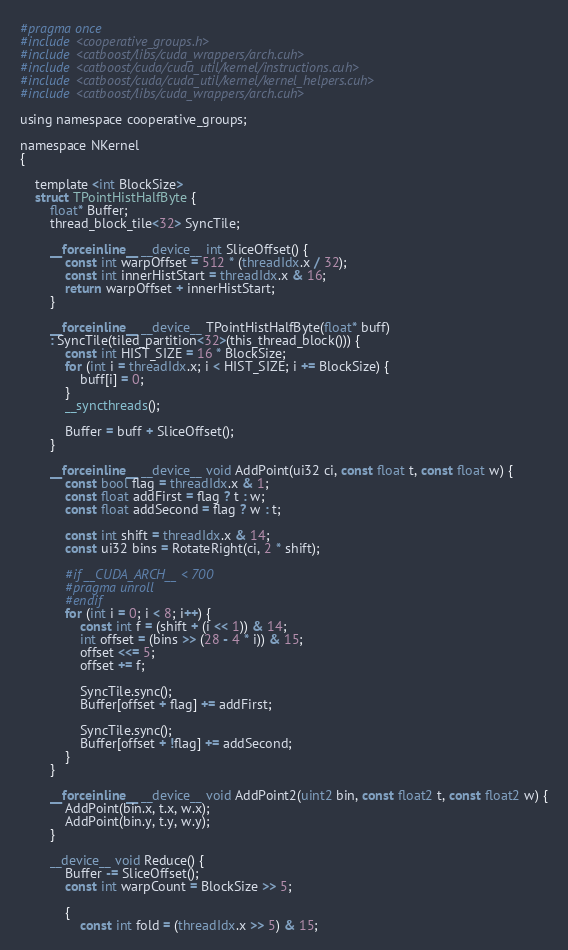<code> <loc_0><loc_0><loc_500><loc_500><_Cuda_>#pragma once
#include <cooperative_groups.h>
#include <catboost/libs/cuda_wrappers/arch.cuh>
#include <catboost/cuda/cuda_util/kernel/instructions.cuh>
#include <catboost/cuda/cuda_util/kernel/kernel_helpers.cuh>
#include <catboost/libs/cuda_wrappers/arch.cuh>

using namespace cooperative_groups;

namespace NKernel
{

    template <int BlockSize>
    struct TPointHistHalfByte {
        float* Buffer;
        thread_block_tile<32> SyncTile;

        __forceinline__ __device__ int SliceOffset() {
            const int warpOffset = 512 * (threadIdx.x / 32);
            const int innerHistStart = threadIdx.x & 16;
            return warpOffset + innerHistStart;
        }

        __forceinline__ __device__ TPointHistHalfByte(float* buff)
        : SyncTile(tiled_partition<32>(this_thread_block())) {
            const int HIST_SIZE = 16 * BlockSize;
            for (int i = threadIdx.x; i < HIST_SIZE; i += BlockSize) {
                buff[i] = 0;
            }
            __syncthreads();

            Buffer = buff + SliceOffset();
        }

        __forceinline__ __device__ void AddPoint(ui32 ci, const float t, const float w) {
            const bool flag = threadIdx.x & 1;
            const float addFirst = flag ? t : w;
            const float addSecond = flag ? w : t;

            const int shift = threadIdx.x & 14;
            const ui32 bins = RotateRight(ci, 2 * shift);

            #if __CUDA_ARCH__ < 700
            #pragma unroll
            #endif
            for (int i = 0; i < 8; i++) {
                const int f = (shift + (i << 1)) & 14;
                int offset = (bins >> (28 - 4 * i)) & 15;
                offset <<= 5;
                offset += f;

                SyncTile.sync();
                Buffer[offset + flag] += addFirst;

                SyncTile.sync();
                Buffer[offset + !flag] += addSecond;
            }
        }

        __forceinline__ __device__ void AddPoint2(uint2 bin, const float2 t, const float2 w) {
            AddPoint(bin.x, t.x, w.x);
            AddPoint(bin.y, t.y, w.y);
        }

        __device__ void Reduce() {
            Buffer -= SliceOffset();
            const int warpCount = BlockSize >> 5;

            {
                const int fold = (threadIdx.x >> 5) & 15;</code> 